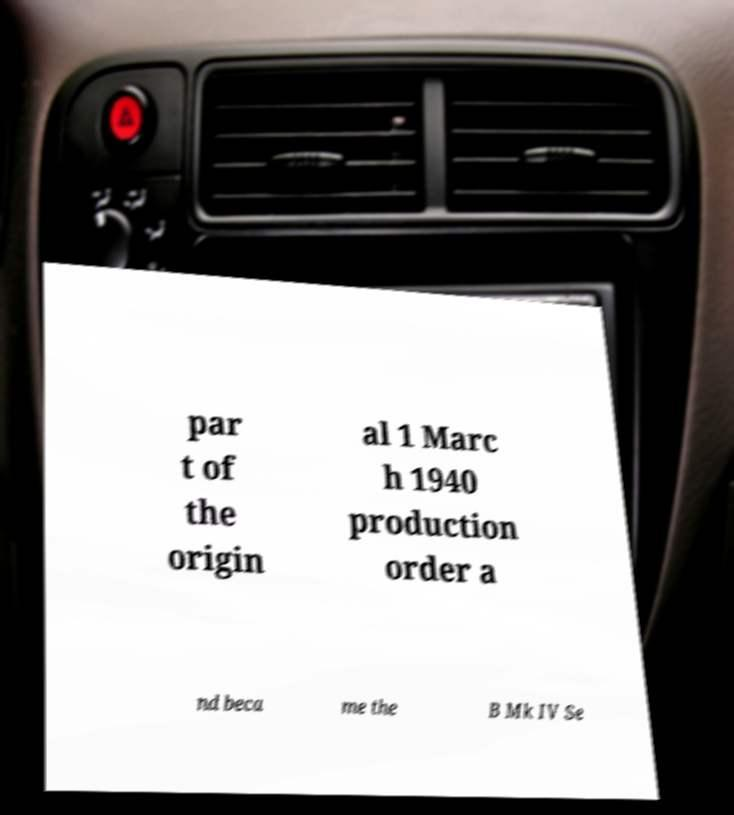I need the written content from this picture converted into text. Can you do that? par t of the origin al 1 Marc h 1940 production order a nd beca me the B Mk IV Se 